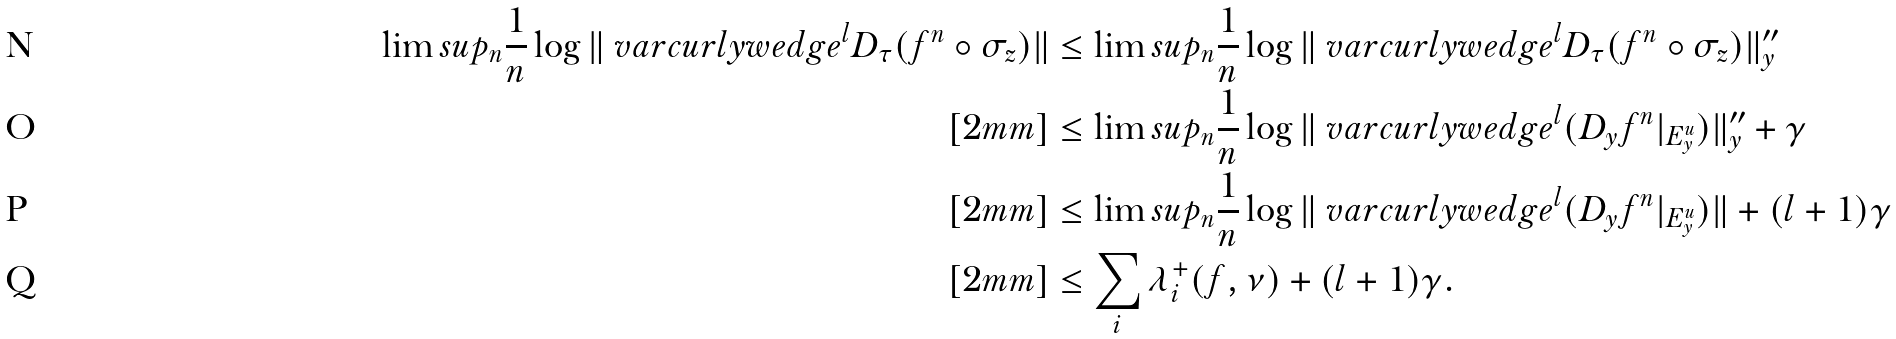<formula> <loc_0><loc_0><loc_500><loc_500>\lim s u p _ { n } \frac { 1 } { n } \log \| \ v a r c u r l y w e d g e ^ { l } D _ { \tau } ( f ^ { n } \circ \sigma _ { z } ) \| & \leq \lim s u p _ { n } \frac { 1 } { n } \log \| \ v a r c u r l y w e d g e ^ { l } D _ { \tau } ( f ^ { n } \circ \sigma _ { z } ) \| ^ { \prime \prime } _ { y } \\ [ 2 m m ] & \leq \lim s u p _ { n } \frac { 1 } { n } \log \| \ v a r c u r l y w e d g e ^ { l } ( D _ { y } f ^ { n } | _ { E ^ { u } _ { y } } ) \| ^ { \prime \prime } _ { y } + \gamma \\ [ 2 m m ] & \leq \lim s u p _ { n } \frac { 1 } { n } \log \| \ v a r c u r l y w e d g e ^ { l } ( D _ { y } f ^ { n } | _ { E ^ { u } _ { y } } ) \| + ( l + 1 ) \gamma \\ [ 2 m m ] & \leq \sum _ { i } \lambda _ { i } ^ { + } ( f , \nu ) + ( l + 1 ) \gamma .</formula> 